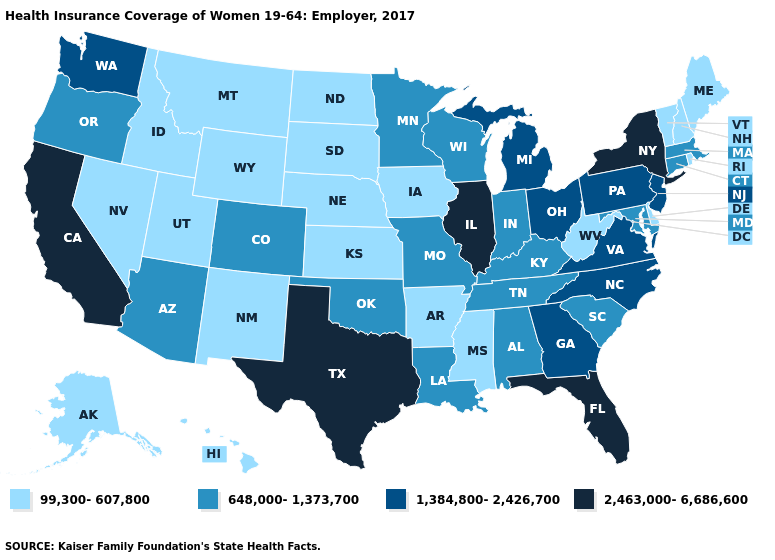What is the value of Rhode Island?
Answer briefly. 99,300-607,800. What is the highest value in states that border Washington?
Be succinct. 648,000-1,373,700. What is the value of Arizona?
Answer briefly. 648,000-1,373,700. What is the lowest value in the MidWest?
Answer briefly. 99,300-607,800. What is the highest value in states that border Oklahoma?
Quick response, please. 2,463,000-6,686,600. Name the states that have a value in the range 2,463,000-6,686,600?
Short answer required. California, Florida, Illinois, New York, Texas. Does Indiana have the lowest value in the MidWest?
Quick response, please. No. What is the value of Indiana?
Concise answer only. 648,000-1,373,700. Does Missouri have the lowest value in the MidWest?
Be succinct. No. Name the states that have a value in the range 648,000-1,373,700?
Concise answer only. Alabama, Arizona, Colorado, Connecticut, Indiana, Kentucky, Louisiana, Maryland, Massachusetts, Minnesota, Missouri, Oklahoma, Oregon, South Carolina, Tennessee, Wisconsin. What is the lowest value in the West?
Quick response, please. 99,300-607,800. Does Oregon have the lowest value in the West?
Keep it brief. No. What is the lowest value in the West?
Keep it brief. 99,300-607,800. Does North Dakota have the lowest value in the MidWest?
Keep it brief. Yes. Name the states that have a value in the range 648,000-1,373,700?
Short answer required. Alabama, Arizona, Colorado, Connecticut, Indiana, Kentucky, Louisiana, Maryland, Massachusetts, Minnesota, Missouri, Oklahoma, Oregon, South Carolina, Tennessee, Wisconsin. 